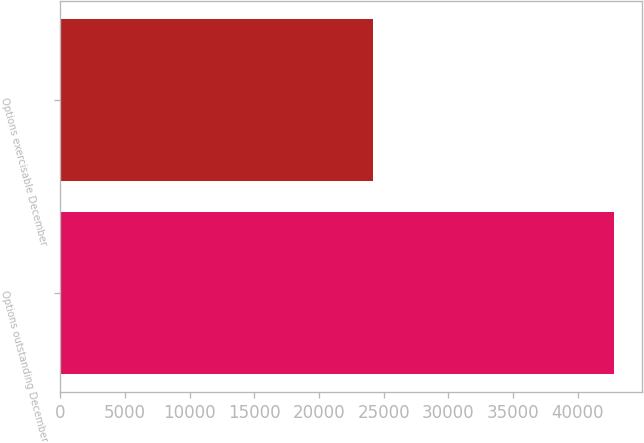<chart> <loc_0><loc_0><loc_500><loc_500><bar_chart><fcel>Options outstanding December<fcel>Options exercisable December<nl><fcel>42832<fcel>24151<nl></chart> 